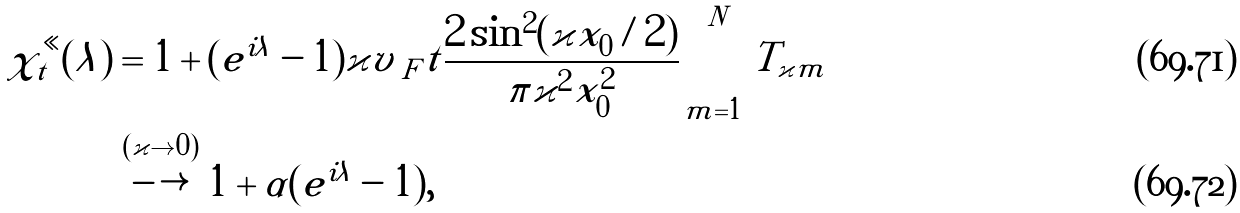Convert formula to latex. <formula><loc_0><loc_0><loc_500><loc_500>\chi _ { t } ^ { \ll } ( \lambda ) & = 1 + ( e ^ { i \lambda } - 1 ) \varkappa v _ { \ F } t \frac { 2 \sin ^ { 2 } ( \varkappa x _ { 0 } / 2 ) } { \pi \varkappa ^ { 2 } x _ { 0 } ^ { 2 } } \sum _ { m = 1 } ^ { N } T _ { \varkappa m } \\ & \stackrel { ( \varkappa \to 0 ) } \longrightarrow 1 + \alpha ( e ^ { i \lambda } - 1 ) ,</formula> 